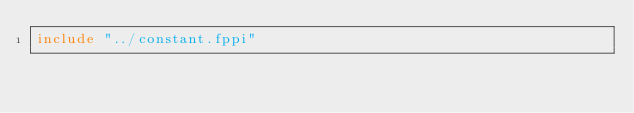<code> <loc_0><loc_0><loc_500><loc_500><_FORTRAN_>include "../constant.fppi"
</code> 